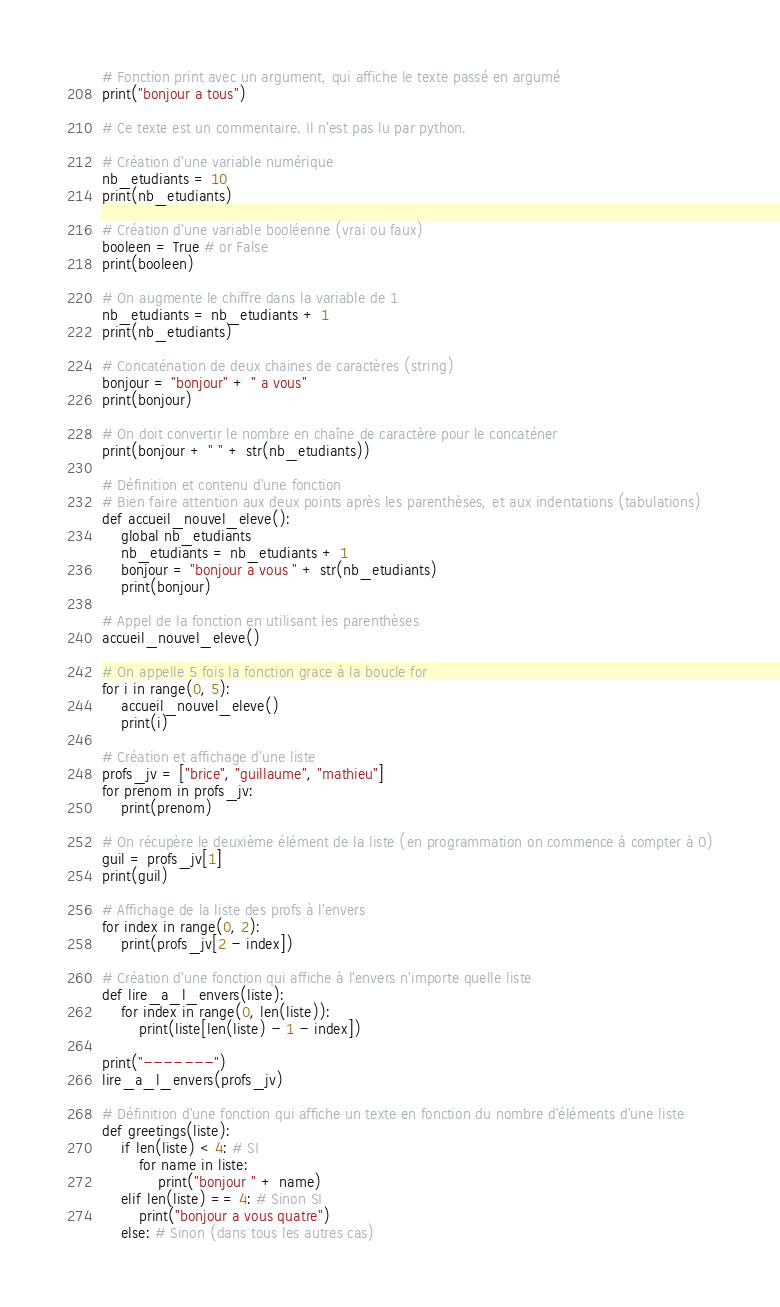Convert code to text. <code><loc_0><loc_0><loc_500><loc_500><_Python_># Fonction print avec un argument, qui affiche le texte passé en argumé
print("bonjour a tous")

# Ce texte est un commentaire. Il n'est pas lu par python.

# Création d'une variable numérique
nb_etudiants = 10
print(nb_etudiants)

# Création d'une variable booléenne (vrai ou faux)
booleen = True # or False
print(booleen)

# On augmente le chiffre dans la variable de 1
nb_etudiants = nb_etudiants + 1
print(nb_etudiants)

# Concaténation de deux chaines de caractères (string)
bonjour = "bonjour" + " a vous"
print(bonjour)

# On doit convertir le nombre en chaîne de caractère pour le concaténer
print(bonjour + " " + str(nb_etudiants))

# Définition et contenu d'une fonction
# Bien faire attention aux deux points après les parenthèses, et aux indentations (tabulations)
def accueil_nouvel_eleve():
    global nb_etudiants
    nb_etudiants = nb_etudiants + 1
    bonjour = "bonjour a vous " + str(nb_etudiants)
    print(bonjour)

# Appel de la fonction en utilisant les parenthèses
accueil_nouvel_eleve()

# On appelle 5 fois la fonction grace à la boucle for
for i in range(0, 5):
    accueil_nouvel_eleve()
    print(i)

# Création et affichage d'une liste
profs_jv = ["brice", "guillaume", "mathieu"]
for prenom in profs_jv:
    print(prenom)

# On récupère le deuxième élément de la liste (en programmation on commence à compter à 0)
guil = profs_jv[1]
print(guil)

# Affichage de la liste des profs à l'envers
for index in range(0, 2):
    print(profs_jv[2 - index])

# Création d'une fonction qui affiche à l'envers n'importe quelle liste
def lire_a_l_envers(liste):
    for index in range(0, len(liste)):
        print(liste[len(liste) - 1 - index])

print("-------")
lire_a_l_envers(profs_jv)

# Définition d'une fonction qui affiche un texte en fonction du nombre d'éléments d'une liste
def greetings(liste):
    if len(liste) < 4: # SI
        for name in liste:
            print("bonjour " + name)
    elif len(liste) == 4: # Sinon SI
        print("bonjour a vous quatre")
    else: # Sinon (dans tous les autres cas)</code> 